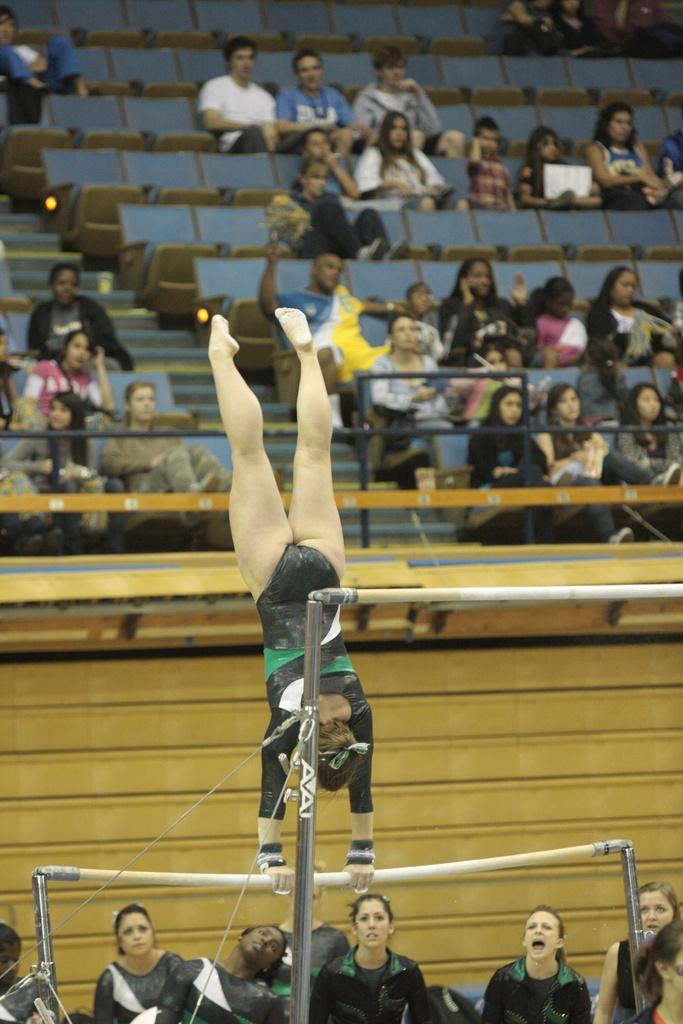<image>
Share a concise interpretation of the image provided. A gymnast performs her routine on a pair of Avai uneven bars. 